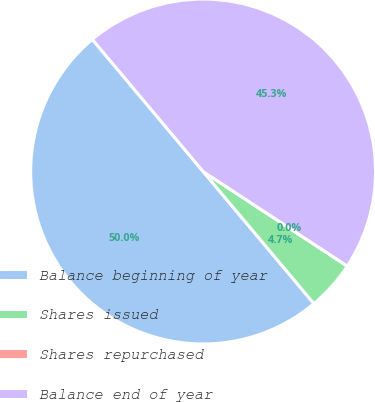<chart> <loc_0><loc_0><loc_500><loc_500><pie_chart><fcel>Balance beginning of year<fcel>Shares issued<fcel>Shares repurchased<fcel>Balance end of year<nl><fcel>50.0%<fcel>4.65%<fcel>0.0%<fcel>45.35%<nl></chart> 